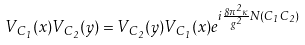Convert formula to latex. <formula><loc_0><loc_0><loc_500><loc_500>V _ { C _ { 1 } } ( x ) V _ { C _ { 2 } } ( y ) = V _ { C _ { 2 } } ( y ) V _ { C _ { 1 } } ( x ) e ^ { i \frac { 8 \pi ^ { 2 } \kappa } { g ^ { 2 } } N ( C _ { 1 } C _ { 2 } ) }</formula> 